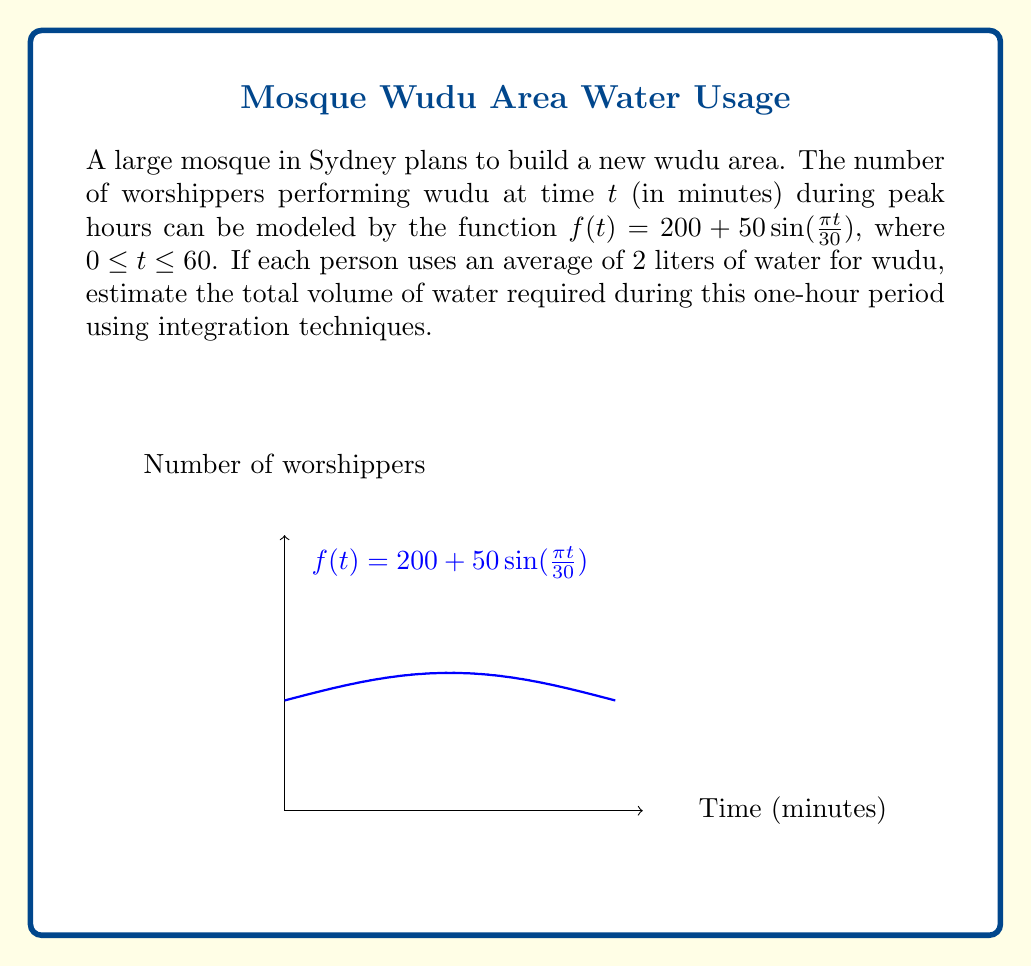Can you answer this question? To solve this problem, we need to follow these steps:

1) The total number of worshippers over the one-hour period is given by the integral of $f(t)$ from 0 to 60:

   $$\int_0^{60} (200 + 50\sin(\frac{\pi t}{30})) dt$$

2) Let's integrate this function:
   
   $$\int_0^{60} 200 dt + \int_0^{60} 50\sin(\frac{\pi t}{30}) dt$$

3) The first part is straightforward:
   
   $$200t \Big|_0^{60} = 12000$$

4) For the second part, we use the substitution $u = \frac{\pi t}{30}$:
   
   $$\frac{1500}{\pi} \int_0^{2\pi} \sin(u) du = -\frac{1500}{\pi} \cos(u) \Big|_0^{2\pi} = 0$$

5) Therefore, the total number of worshippers is 12000.

6) Since each person uses 2 liters of water, we multiply the result by 2:

   $$12000 \times 2 = 24000 \text{ liters}$$
Answer: 24000 liters 